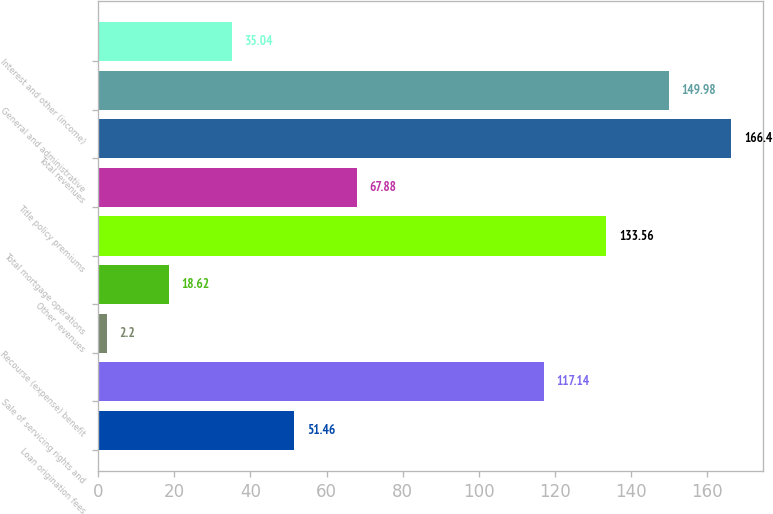Convert chart to OTSL. <chart><loc_0><loc_0><loc_500><loc_500><bar_chart><fcel>Loan origination fees<fcel>Sale of servicing rights and<fcel>Recourse (expense) benefit<fcel>Other revenues<fcel>Total mortgage operations<fcel>Title policy premiums<fcel>Total revenues<fcel>General and administrative<fcel>Interest and other (income)<nl><fcel>51.46<fcel>117.14<fcel>2.2<fcel>18.62<fcel>133.56<fcel>67.88<fcel>166.4<fcel>149.98<fcel>35.04<nl></chart> 